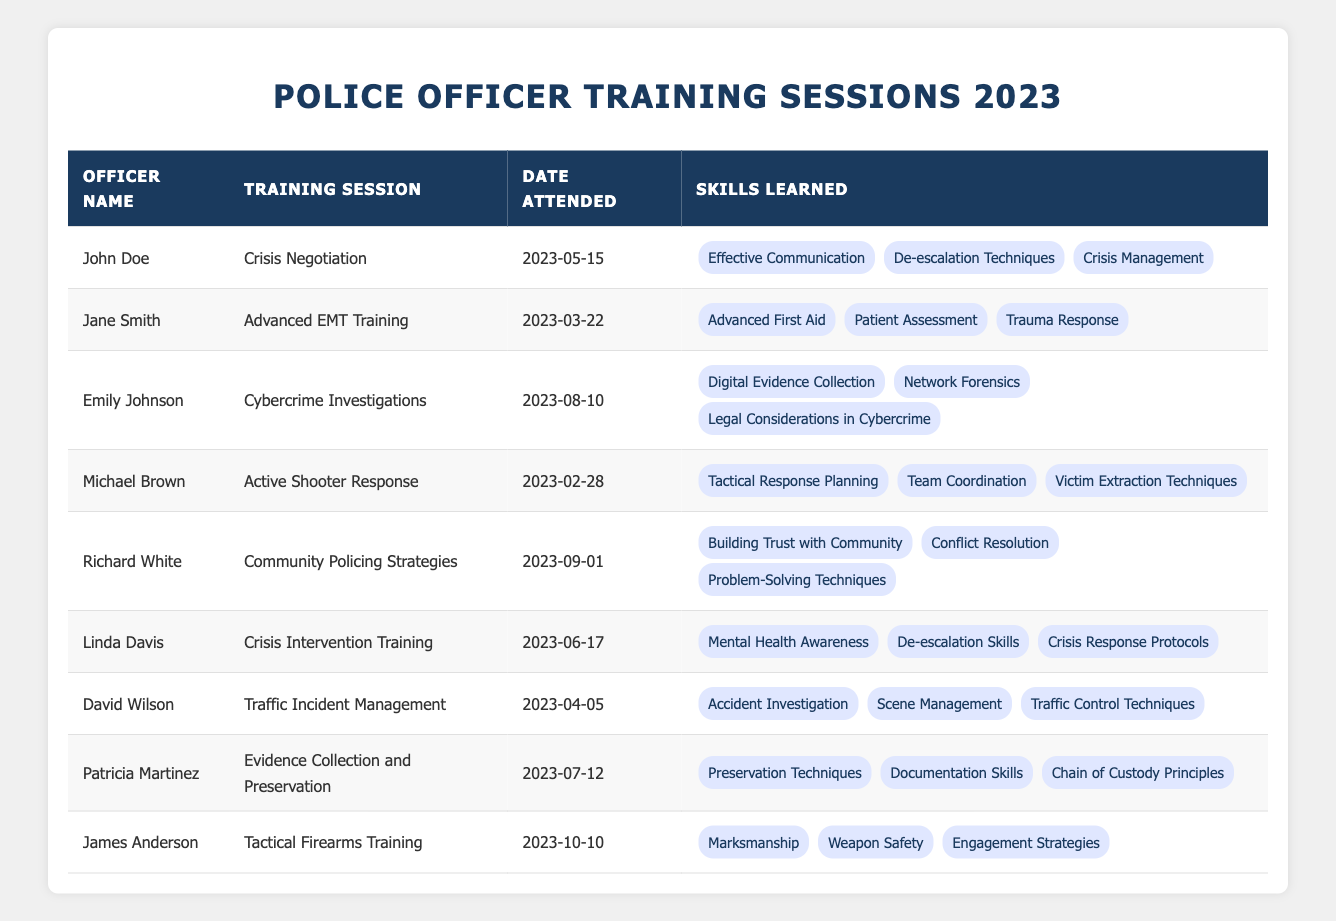What training session did John Doe attend? The table lists the training sessions along with the officers' names. I look for John Doe in the first column, and see that he attended the "Crisis Negotiation" training session.
Answer: Crisis Negotiation How many skills did Emily Johnson learn in her training? By referencing the skills learned by Emily Johnson in the table, I count the number of skills listed for her training session "Cybercrime Investigations," which are three: "Digital Evidence Collection," "Network Forensics," and "Legal Considerations in Cybercrime."
Answer: 3 Who attended "Traffic Incident Management"? I look at the "Training Session" column in the table and find "Traffic Incident Management." The officer listed next to that session is David Wilson.
Answer: David Wilson Did Linda Davis learn "Mental Health Awareness"? Checking the skills learned by Linda Davis in the table under her training session "Crisis Intervention Training," I find "Mental Health Awareness" listed. Therefore, the answer is yes.
Answer: Yes Which officer's training session was held the earliest? I review the "Date Attended" column for all officers to determine the earliest date. The earliest date listed is 2023-02-28, attended by Michael Brown for "Active Shooter Response."
Answer: Michael Brown What skills did Patricia Martinez acquire from her training? Looking at the table, I check the skills listed under Patricia Martinez for her training session "Evidence Collection and Preservation," which include "Preservation Techniques," "Documentation Skills," and "Chain of Custody Principles."
Answer: Preservation Techniques, Documentation Skills, Chain of Custody Principles Was there any officer who attended a training session in June? I scan through the "Date Attended" column looking for any entries in June, and I find that Linda Davis attended a session on 2023-06-17. Thus, the answer is yes.
Answer: Yes How many officers attended sessions focused on crisis management? I check the table entries and identify that three officers attended sessions related to crisis management: John Doe (Crisis Negotiation), Linda Davis (Crisis Intervention Training), and Michael Brown (Active Shooter Response). So, I count them, which gives me three officers.
Answer: 3 Which training session included skills on "De-escalation Techniques"? I browse through the table and find that both John Doe's "Crisis Negotiation" and Linda Davis's "Crisis Intervention Training" sessions list "De-escalation Techniques" as a skill learned.
Answer: Crisis Negotiation, Crisis Intervention Training What is the most recent training session attended according to the table? I look through the "Date Attended" column to find the latest date. The most recent date is 2023-10-10, attended by James Anderson for "Tactical Firearms Training."
Answer: Tactical Firearms Training 